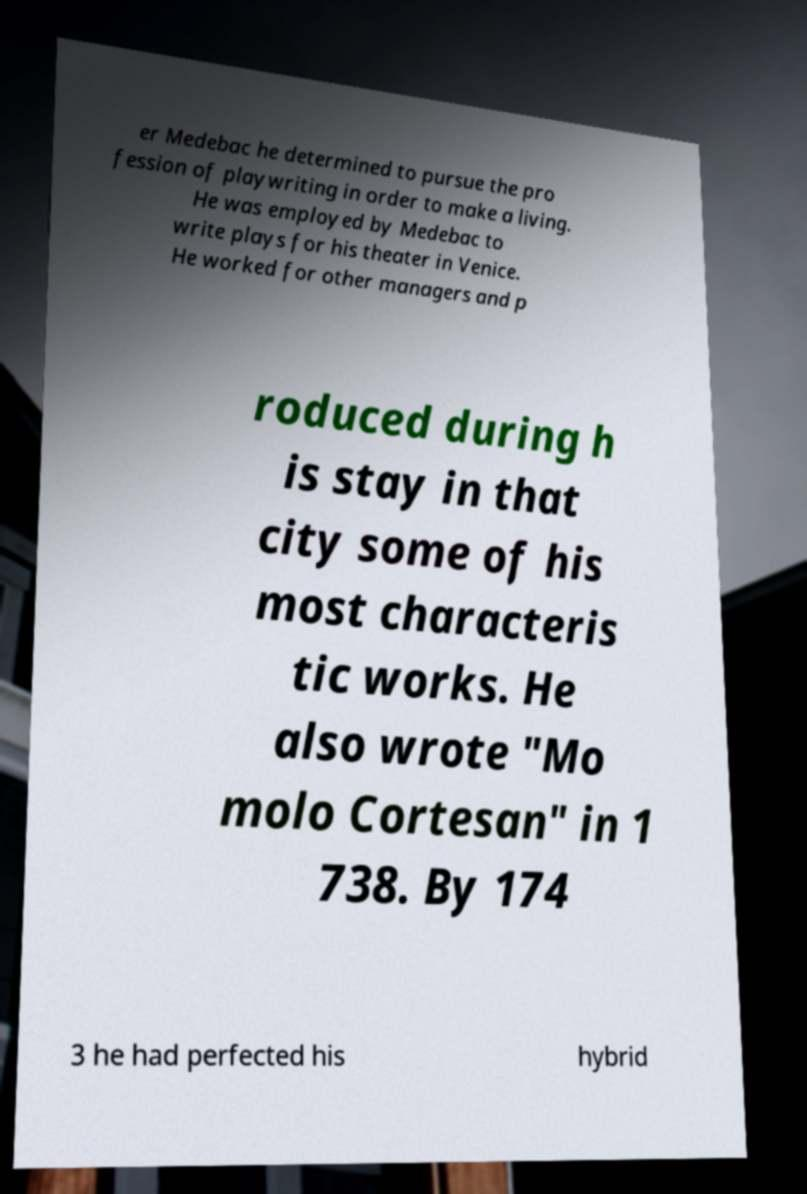Can you read and provide the text displayed in the image?This photo seems to have some interesting text. Can you extract and type it out for me? er Medebac he determined to pursue the pro fession of playwriting in order to make a living. He was employed by Medebac to write plays for his theater in Venice. He worked for other managers and p roduced during h is stay in that city some of his most characteris tic works. He also wrote "Mo molo Cortesan" in 1 738. By 174 3 he had perfected his hybrid 